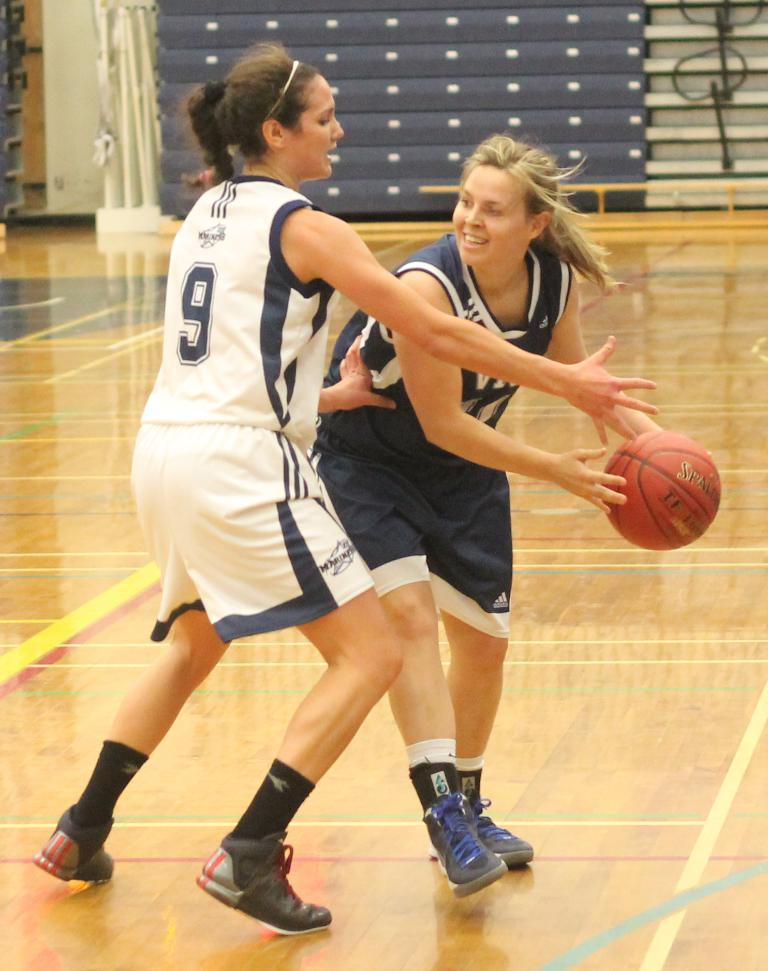Provide a one-sentence caption for the provided image. a couple of women playing a game of basketball one with the number 9. 